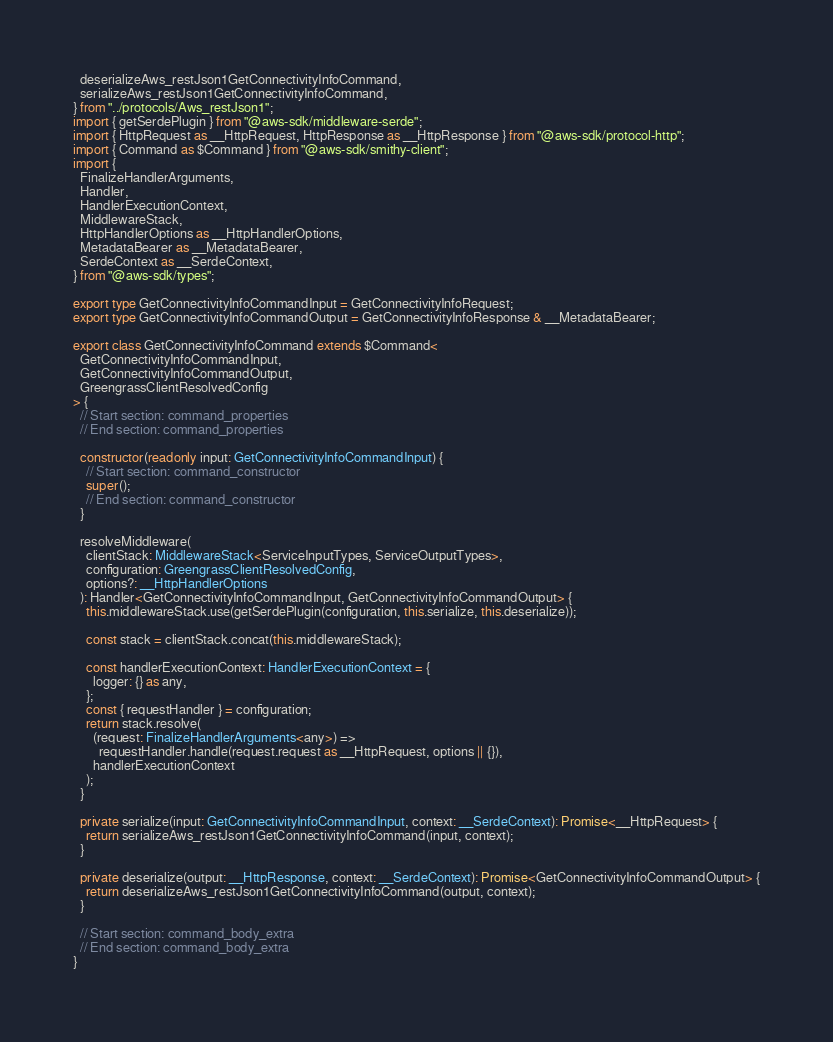<code> <loc_0><loc_0><loc_500><loc_500><_TypeScript_>  deserializeAws_restJson1GetConnectivityInfoCommand,
  serializeAws_restJson1GetConnectivityInfoCommand,
} from "../protocols/Aws_restJson1";
import { getSerdePlugin } from "@aws-sdk/middleware-serde";
import { HttpRequest as __HttpRequest, HttpResponse as __HttpResponse } from "@aws-sdk/protocol-http";
import { Command as $Command } from "@aws-sdk/smithy-client";
import {
  FinalizeHandlerArguments,
  Handler,
  HandlerExecutionContext,
  MiddlewareStack,
  HttpHandlerOptions as __HttpHandlerOptions,
  MetadataBearer as __MetadataBearer,
  SerdeContext as __SerdeContext,
} from "@aws-sdk/types";

export type GetConnectivityInfoCommandInput = GetConnectivityInfoRequest;
export type GetConnectivityInfoCommandOutput = GetConnectivityInfoResponse & __MetadataBearer;

export class GetConnectivityInfoCommand extends $Command<
  GetConnectivityInfoCommandInput,
  GetConnectivityInfoCommandOutput,
  GreengrassClientResolvedConfig
> {
  // Start section: command_properties
  // End section: command_properties

  constructor(readonly input: GetConnectivityInfoCommandInput) {
    // Start section: command_constructor
    super();
    // End section: command_constructor
  }

  resolveMiddleware(
    clientStack: MiddlewareStack<ServiceInputTypes, ServiceOutputTypes>,
    configuration: GreengrassClientResolvedConfig,
    options?: __HttpHandlerOptions
  ): Handler<GetConnectivityInfoCommandInput, GetConnectivityInfoCommandOutput> {
    this.middlewareStack.use(getSerdePlugin(configuration, this.serialize, this.deserialize));

    const stack = clientStack.concat(this.middlewareStack);

    const handlerExecutionContext: HandlerExecutionContext = {
      logger: {} as any,
    };
    const { requestHandler } = configuration;
    return stack.resolve(
      (request: FinalizeHandlerArguments<any>) =>
        requestHandler.handle(request.request as __HttpRequest, options || {}),
      handlerExecutionContext
    );
  }

  private serialize(input: GetConnectivityInfoCommandInput, context: __SerdeContext): Promise<__HttpRequest> {
    return serializeAws_restJson1GetConnectivityInfoCommand(input, context);
  }

  private deserialize(output: __HttpResponse, context: __SerdeContext): Promise<GetConnectivityInfoCommandOutput> {
    return deserializeAws_restJson1GetConnectivityInfoCommand(output, context);
  }

  // Start section: command_body_extra
  // End section: command_body_extra
}
</code> 